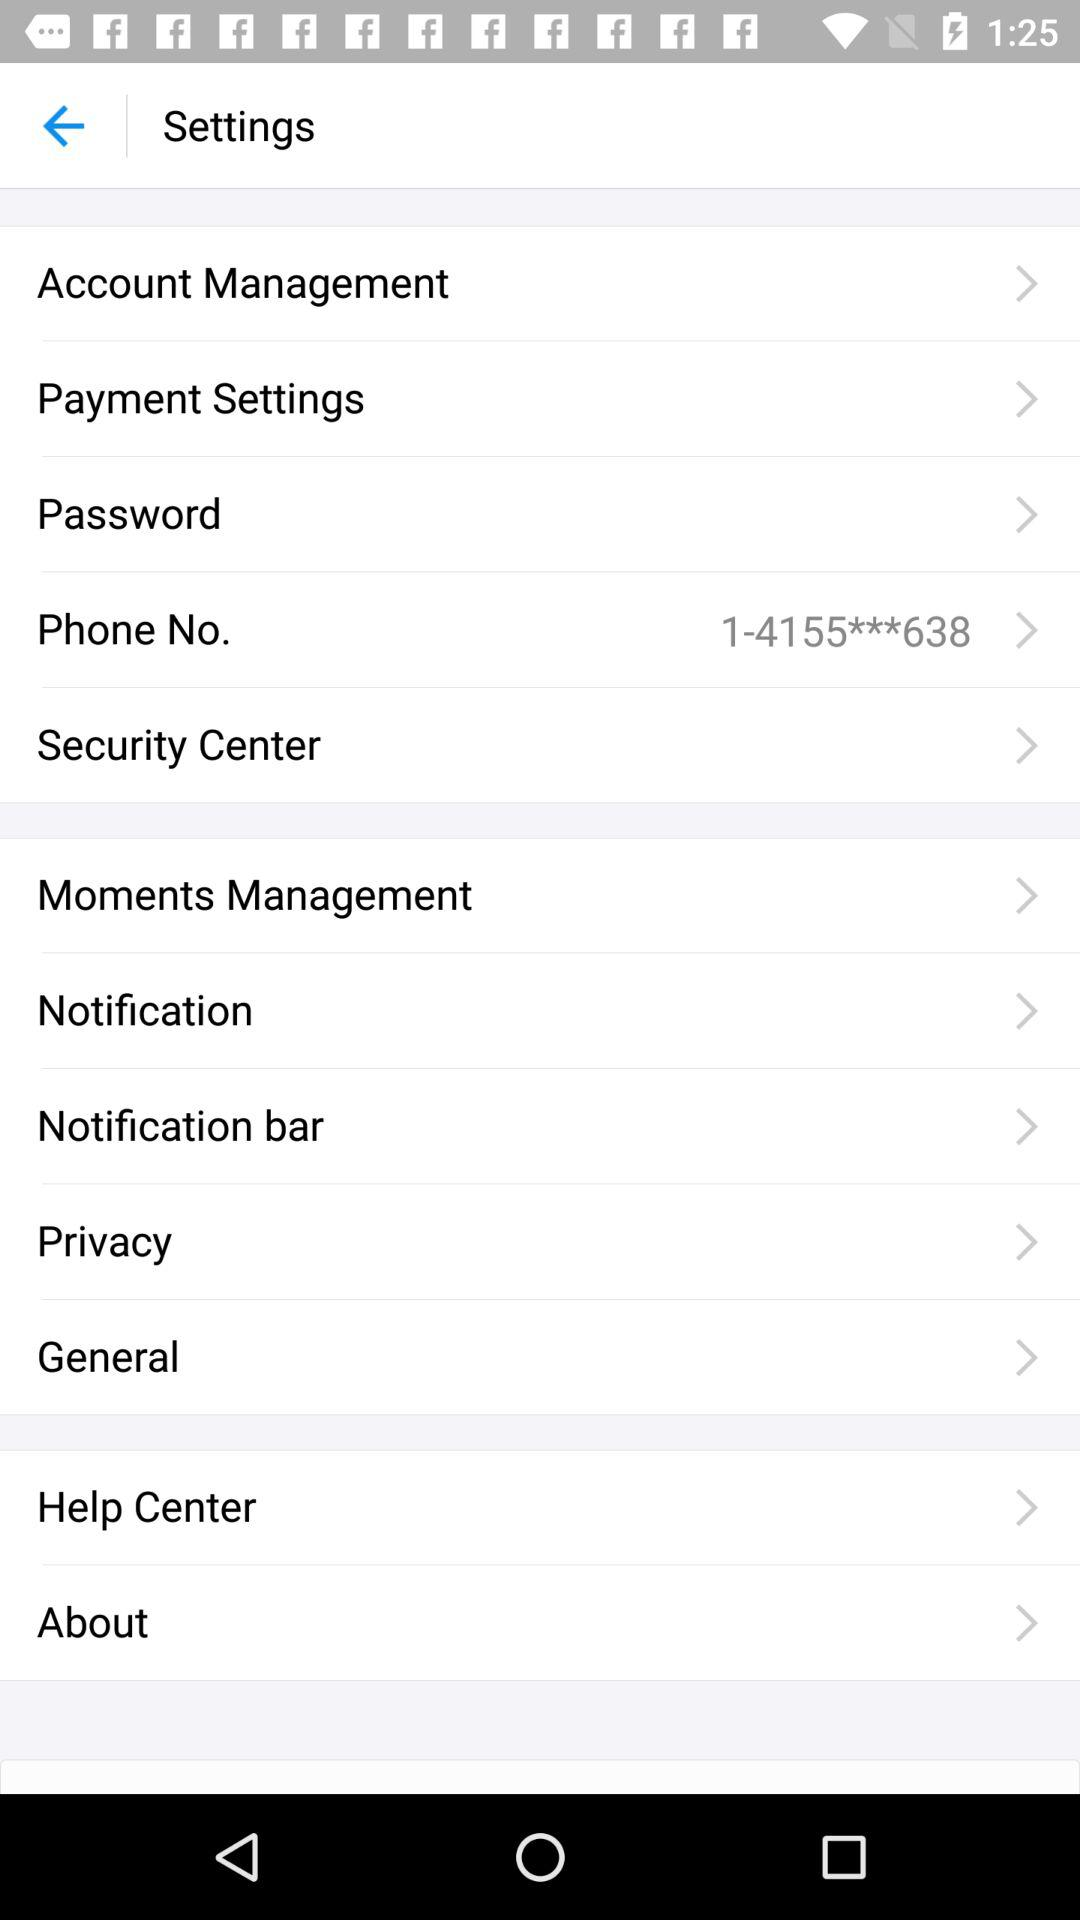What is the phone number? The phone number is 1-4155***638. 